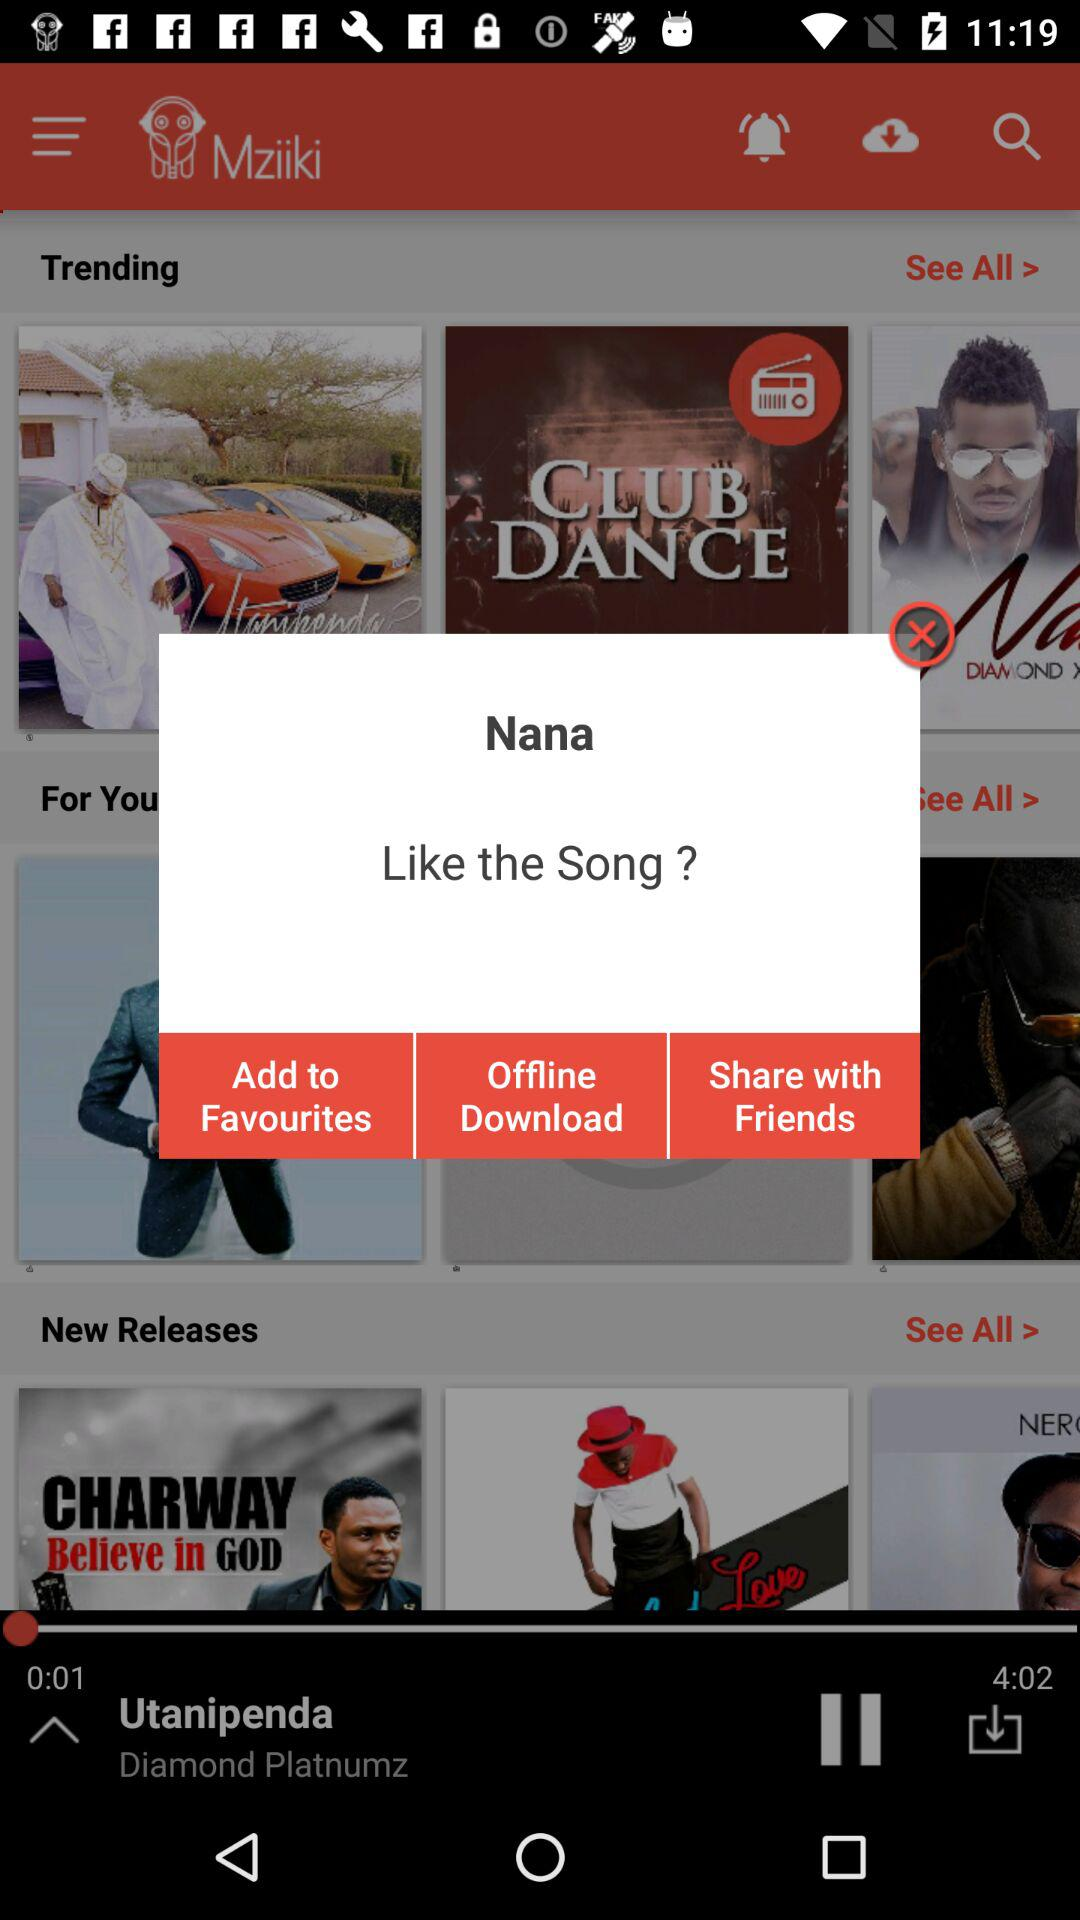What song is mentioned on the screen for liking? The mentioned song on the screen is "Nana". 